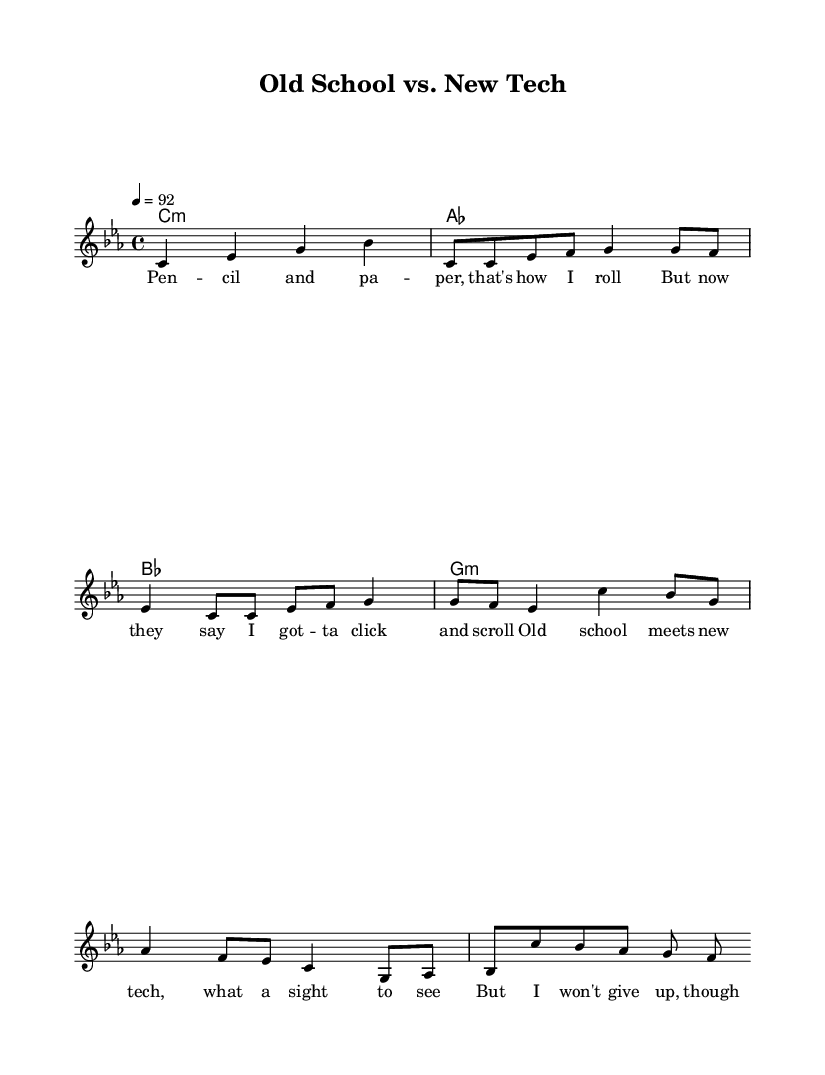What is the key signature of this music? The key signature indicated in the music sheet is C minor, which has three flats (B♭, E♭, and A♭).
Answer: C minor What is the time signature of this music? The time signature shown at the beginning of the piece is 4/4, meaning there are four beats in each measure and the quarter note gets one beat.
Answer: 4/4 What is the tempo marking for this music? The tempo marking states "4 = 92," which means there are 92 beats per minute, specifically for quarter notes.
Answer: 92 How many times is the verse repeated in the melody? The notation indicates a repeat sign followed by "unfold," specifying that the verse is to be played two times.
Answer: 2 What type of instrument is used in this score? The score is centered around vocal melody with a piano-style accompaniment, which suggests it is designed for voice with instrumental support.
Answer: Voice What is the main theme expressed in the lyrics? The lyrics highlight the contrast between traditional methods (using a pencil and paper) and the new technology of computers, showcasing humorous challenges.
Answer: Technology What is the structure of the music in terms of sections? The structure consists of an introductory section followed by verses, a chorus, and a bridge, indicating a common form in rap music.
Answer: Intro, Verse, Chorus, Bridge 